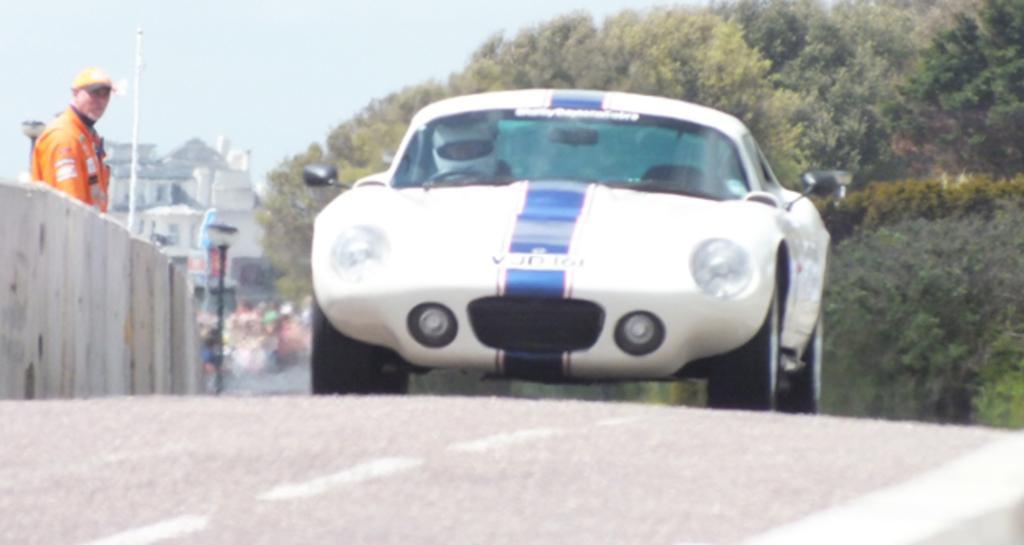Can you describe this image briefly? In this picture we can see a car on the road and a man standing at the fence, trees, buildings and in the background we can see the sky. 